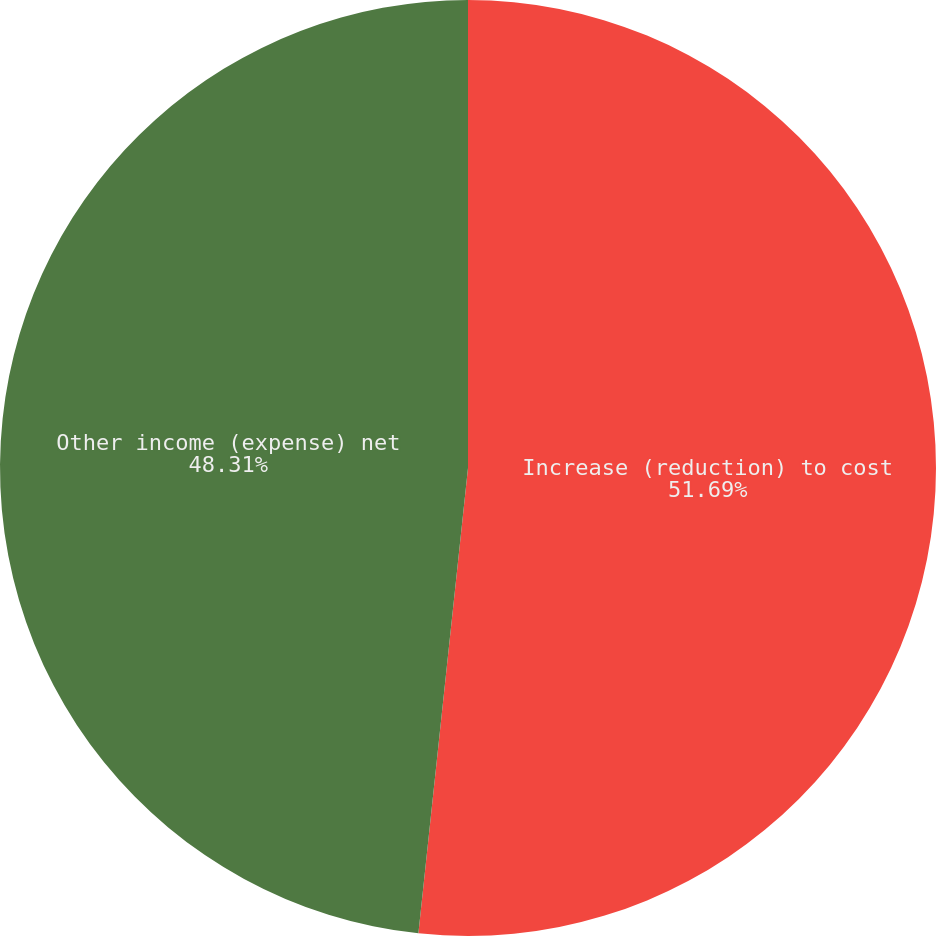Convert chart. <chart><loc_0><loc_0><loc_500><loc_500><pie_chart><fcel>Increase (reduction) to cost<fcel>Other income (expense) net<nl><fcel>51.69%<fcel>48.31%<nl></chart> 